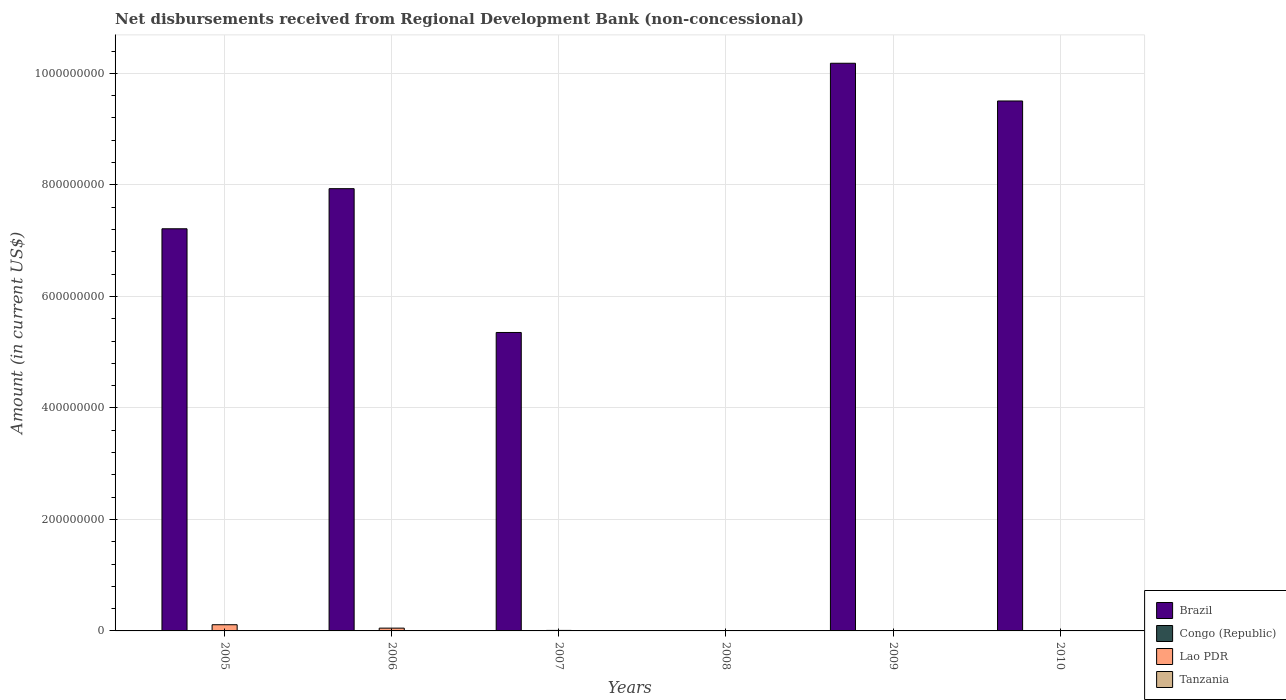How many different coloured bars are there?
Give a very brief answer. 2. Are the number of bars per tick equal to the number of legend labels?
Ensure brevity in your answer.  No. How many bars are there on the 5th tick from the left?
Give a very brief answer. 2. In how many cases, is the number of bars for a given year not equal to the number of legend labels?
Provide a succinct answer. 6. What is the amount of disbursements received from Regional Development Bank in Congo (Republic) in 2009?
Make the answer very short. 0. Across all years, what is the maximum amount of disbursements received from Regional Development Bank in Lao PDR?
Offer a very short reply. 1.11e+07. What is the total amount of disbursements received from Regional Development Bank in Congo (Republic) in the graph?
Your answer should be very brief. 0. What is the difference between the amount of disbursements received from Regional Development Bank in Lao PDR in 2008 and that in 2009?
Your response must be concise. 2.93e+05. What is the difference between the amount of disbursements received from Regional Development Bank in Tanzania in 2008 and the amount of disbursements received from Regional Development Bank in Brazil in 2009?
Your response must be concise. -1.02e+09. What is the average amount of disbursements received from Regional Development Bank in Brazil per year?
Your answer should be compact. 6.70e+08. In the year 2010, what is the difference between the amount of disbursements received from Regional Development Bank in Brazil and amount of disbursements received from Regional Development Bank in Lao PDR?
Provide a succinct answer. 9.50e+08. What is the ratio of the amount of disbursements received from Regional Development Bank in Brazil in 2006 to that in 2010?
Your answer should be compact. 0.83. Is the amount of disbursements received from Regional Development Bank in Lao PDR in 2007 less than that in 2008?
Offer a very short reply. No. What is the difference between the highest and the second highest amount of disbursements received from Regional Development Bank in Brazil?
Give a very brief answer. 6.77e+07. What is the difference between the highest and the lowest amount of disbursements received from Regional Development Bank in Brazil?
Your answer should be very brief. 1.02e+09. In how many years, is the amount of disbursements received from Regional Development Bank in Lao PDR greater than the average amount of disbursements received from Regional Development Bank in Lao PDR taken over all years?
Make the answer very short. 2. How many bars are there?
Your answer should be compact. 11. Does the graph contain any zero values?
Offer a very short reply. Yes. How many legend labels are there?
Your response must be concise. 4. How are the legend labels stacked?
Offer a very short reply. Vertical. What is the title of the graph?
Provide a short and direct response. Net disbursements received from Regional Development Bank (non-concessional). What is the label or title of the X-axis?
Make the answer very short. Years. What is the Amount (in current US$) in Brazil in 2005?
Your answer should be compact. 7.21e+08. What is the Amount (in current US$) of Lao PDR in 2005?
Offer a very short reply. 1.11e+07. What is the Amount (in current US$) of Tanzania in 2005?
Provide a succinct answer. 0. What is the Amount (in current US$) of Brazil in 2006?
Provide a succinct answer. 7.93e+08. What is the Amount (in current US$) in Lao PDR in 2006?
Give a very brief answer. 4.99e+06. What is the Amount (in current US$) of Brazil in 2007?
Offer a very short reply. 5.35e+08. What is the Amount (in current US$) of Lao PDR in 2007?
Your answer should be very brief. 9.09e+05. What is the Amount (in current US$) in Lao PDR in 2008?
Your answer should be very brief. 7.44e+05. What is the Amount (in current US$) in Tanzania in 2008?
Offer a very short reply. 0. What is the Amount (in current US$) of Brazil in 2009?
Ensure brevity in your answer.  1.02e+09. What is the Amount (in current US$) of Congo (Republic) in 2009?
Offer a terse response. 0. What is the Amount (in current US$) in Lao PDR in 2009?
Make the answer very short. 4.51e+05. What is the Amount (in current US$) in Tanzania in 2009?
Offer a very short reply. 0. What is the Amount (in current US$) of Brazil in 2010?
Provide a succinct answer. 9.51e+08. What is the Amount (in current US$) in Lao PDR in 2010?
Keep it short and to the point. 1.52e+05. What is the Amount (in current US$) in Tanzania in 2010?
Offer a terse response. 0. Across all years, what is the maximum Amount (in current US$) in Brazil?
Keep it short and to the point. 1.02e+09. Across all years, what is the maximum Amount (in current US$) of Lao PDR?
Provide a short and direct response. 1.11e+07. Across all years, what is the minimum Amount (in current US$) of Lao PDR?
Offer a very short reply. 1.52e+05. What is the total Amount (in current US$) in Brazil in the graph?
Keep it short and to the point. 4.02e+09. What is the total Amount (in current US$) in Lao PDR in the graph?
Offer a terse response. 1.83e+07. What is the difference between the Amount (in current US$) of Brazil in 2005 and that in 2006?
Keep it short and to the point. -7.19e+07. What is the difference between the Amount (in current US$) of Lao PDR in 2005 and that in 2006?
Provide a short and direct response. 6.11e+06. What is the difference between the Amount (in current US$) of Brazil in 2005 and that in 2007?
Make the answer very short. 1.86e+08. What is the difference between the Amount (in current US$) of Lao PDR in 2005 and that in 2007?
Offer a very short reply. 1.02e+07. What is the difference between the Amount (in current US$) of Lao PDR in 2005 and that in 2008?
Offer a very short reply. 1.04e+07. What is the difference between the Amount (in current US$) in Brazil in 2005 and that in 2009?
Keep it short and to the point. -2.97e+08. What is the difference between the Amount (in current US$) in Lao PDR in 2005 and that in 2009?
Make the answer very short. 1.06e+07. What is the difference between the Amount (in current US$) of Brazil in 2005 and that in 2010?
Keep it short and to the point. -2.29e+08. What is the difference between the Amount (in current US$) in Lao PDR in 2005 and that in 2010?
Your answer should be compact. 1.09e+07. What is the difference between the Amount (in current US$) of Brazil in 2006 and that in 2007?
Keep it short and to the point. 2.58e+08. What is the difference between the Amount (in current US$) of Lao PDR in 2006 and that in 2007?
Your response must be concise. 4.08e+06. What is the difference between the Amount (in current US$) in Lao PDR in 2006 and that in 2008?
Keep it short and to the point. 4.24e+06. What is the difference between the Amount (in current US$) in Brazil in 2006 and that in 2009?
Your response must be concise. -2.25e+08. What is the difference between the Amount (in current US$) of Lao PDR in 2006 and that in 2009?
Offer a terse response. 4.54e+06. What is the difference between the Amount (in current US$) in Brazil in 2006 and that in 2010?
Keep it short and to the point. -1.57e+08. What is the difference between the Amount (in current US$) of Lao PDR in 2006 and that in 2010?
Your answer should be compact. 4.84e+06. What is the difference between the Amount (in current US$) of Lao PDR in 2007 and that in 2008?
Make the answer very short. 1.65e+05. What is the difference between the Amount (in current US$) of Brazil in 2007 and that in 2009?
Your response must be concise. -4.83e+08. What is the difference between the Amount (in current US$) in Lao PDR in 2007 and that in 2009?
Make the answer very short. 4.58e+05. What is the difference between the Amount (in current US$) of Brazil in 2007 and that in 2010?
Offer a very short reply. -4.15e+08. What is the difference between the Amount (in current US$) in Lao PDR in 2007 and that in 2010?
Your answer should be very brief. 7.57e+05. What is the difference between the Amount (in current US$) of Lao PDR in 2008 and that in 2009?
Provide a short and direct response. 2.93e+05. What is the difference between the Amount (in current US$) of Lao PDR in 2008 and that in 2010?
Offer a very short reply. 5.92e+05. What is the difference between the Amount (in current US$) in Brazil in 2009 and that in 2010?
Offer a terse response. 6.77e+07. What is the difference between the Amount (in current US$) of Lao PDR in 2009 and that in 2010?
Make the answer very short. 2.99e+05. What is the difference between the Amount (in current US$) of Brazil in 2005 and the Amount (in current US$) of Lao PDR in 2006?
Provide a succinct answer. 7.16e+08. What is the difference between the Amount (in current US$) of Brazil in 2005 and the Amount (in current US$) of Lao PDR in 2007?
Offer a terse response. 7.20e+08. What is the difference between the Amount (in current US$) in Brazil in 2005 and the Amount (in current US$) in Lao PDR in 2008?
Your response must be concise. 7.21e+08. What is the difference between the Amount (in current US$) of Brazil in 2005 and the Amount (in current US$) of Lao PDR in 2009?
Keep it short and to the point. 7.21e+08. What is the difference between the Amount (in current US$) of Brazil in 2005 and the Amount (in current US$) of Lao PDR in 2010?
Your answer should be very brief. 7.21e+08. What is the difference between the Amount (in current US$) of Brazil in 2006 and the Amount (in current US$) of Lao PDR in 2007?
Offer a terse response. 7.92e+08. What is the difference between the Amount (in current US$) in Brazil in 2006 and the Amount (in current US$) in Lao PDR in 2008?
Offer a terse response. 7.92e+08. What is the difference between the Amount (in current US$) of Brazil in 2006 and the Amount (in current US$) of Lao PDR in 2009?
Your answer should be very brief. 7.93e+08. What is the difference between the Amount (in current US$) of Brazil in 2006 and the Amount (in current US$) of Lao PDR in 2010?
Your answer should be very brief. 7.93e+08. What is the difference between the Amount (in current US$) of Brazil in 2007 and the Amount (in current US$) of Lao PDR in 2008?
Offer a very short reply. 5.35e+08. What is the difference between the Amount (in current US$) in Brazil in 2007 and the Amount (in current US$) in Lao PDR in 2009?
Provide a short and direct response. 5.35e+08. What is the difference between the Amount (in current US$) of Brazil in 2007 and the Amount (in current US$) of Lao PDR in 2010?
Give a very brief answer. 5.35e+08. What is the difference between the Amount (in current US$) of Brazil in 2009 and the Amount (in current US$) of Lao PDR in 2010?
Your answer should be very brief. 1.02e+09. What is the average Amount (in current US$) in Brazil per year?
Provide a succinct answer. 6.70e+08. What is the average Amount (in current US$) of Congo (Republic) per year?
Provide a succinct answer. 0. What is the average Amount (in current US$) of Lao PDR per year?
Your answer should be compact. 3.06e+06. What is the average Amount (in current US$) in Tanzania per year?
Keep it short and to the point. 0. In the year 2005, what is the difference between the Amount (in current US$) of Brazil and Amount (in current US$) of Lao PDR?
Offer a very short reply. 7.10e+08. In the year 2006, what is the difference between the Amount (in current US$) of Brazil and Amount (in current US$) of Lao PDR?
Offer a terse response. 7.88e+08. In the year 2007, what is the difference between the Amount (in current US$) of Brazil and Amount (in current US$) of Lao PDR?
Your answer should be compact. 5.34e+08. In the year 2009, what is the difference between the Amount (in current US$) of Brazil and Amount (in current US$) of Lao PDR?
Give a very brief answer. 1.02e+09. In the year 2010, what is the difference between the Amount (in current US$) of Brazil and Amount (in current US$) of Lao PDR?
Keep it short and to the point. 9.50e+08. What is the ratio of the Amount (in current US$) in Brazil in 2005 to that in 2006?
Your response must be concise. 0.91. What is the ratio of the Amount (in current US$) in Lao PDR in 2005 to that in 2006?
Ensure brevity in your answer.  2.23. What is the ratio of the Amount (in current US$) in Brazil in 2005 to that in 2007?
Give a very brief answer. 1.35. What is the ratio of the Amount (in current US$) of Lao PDR in 2005 to that in 2007?
Your answer should be very brief. 12.21. What is the ratio of the Amount (in current US$) of Lao PDR in 2005 to that in 2008?
Your response must be concise. 14.92. What is the ratio of the Amount (in current US$) of Brazil in 2005 to that in 2009?
Give a very brief answer. 0.71. What is the ratio of the Amount (in current US$) of Lao PDR in 2005 to that in 2009?
Offer a terse response. 24.61. What is the ratio of the Amount (in current US$) in Brazil in 2005 to that in 2010?
Offer a terse response. 0.76. What is the ratio of the Amount (in current US$) of Lao PDR in 2005 to that in 2010?
Offer a very short reply. 73.03. What is the ratio of the Amount (in current US$) in Brazil in 2006 to that in 2007?
Offer a very short reply. 1.48. What is the ratio of the Amount (in current US$) of Lao PDR in 2006 to that in 2007?
Your answer should be very brief. 5.49. What is the ratio of the Amount (in current US$) in Lao PDR in 2006 to that in 2008?
Keep it short and to the point. 6.71. What is the ratio of the Amount (in current US$) in Brazil in 2006 to that in 2009?
Your answer should be compact. 0.78. What is the ratio of the Amount (in current US$) in Lao PDR in 2006 to that in 2009?
Give a very brief answer. 11.06. What is the ratio of the Amount (in current US$) in Brazil in 2006 to that in 2010?
Make the answer very short. 0.83. What is the ratio of the Amount (in current US$) of Lao PDR in 2006 to that in 2010?
Provide a succinct answer. 32.82. What is the ratio of the Amount (in current US$) of Lao PDR in 2007 to that in 2008?
Give a very brief answer. 1.22. What is the ratio of the Amount (in current US$) of Brazil in 2007 to that in 2009?
Your answer should be very brief. 0.53. What is the ratio of the Amount (in current US$) of Lao PDR in 2007 to that in 2009?
Offer a terse response. 2.02. What is the ratio of the Amount (in current US$) in Brazil in 2007 to that in 2010?
Your response must be concise. 0.56. What is the ratio of the Amount (in current US$) in Lao PDR in 2007 to that in 2010?
Keep it short and to the point. 5.98. What is the ratio of the Amount (in current US$) in Lao PDR in 2008 to that in 2009?
Ensure brevity in your answer.  1.65. What is the ratio of the Amount (in current US$) of Lao PDR in 2008 to that in 2010?
Your response must be concise. 4.89. What is the ratio of the Amount (in current US$) of Brazil in 2009 to that in 2010?
Your response must be concise. 1.07. What is the ratio of the Amount (in current US$) in Lao PDR in 2009 to that in 2010?
Offer a very short reply. 2.97. What is the difference between the highest and the second highest Amount (in current US$) of Brazil?
Give a very brief answer. 6.77e+07. What is the difference between the highest and the second highest Amount (in current US$) in Lao PDR?
Give a very brief answer. 6.11e+06. What is the difference between the highest and the lowest Amount (in current US$) of Brazil?
Provide a short and direct response. 1.02e+09. What is the difference between the highest and the lowest Amount (in current US$) of Lao PDR?
Your answer should be very brief. 1.09e+07. 